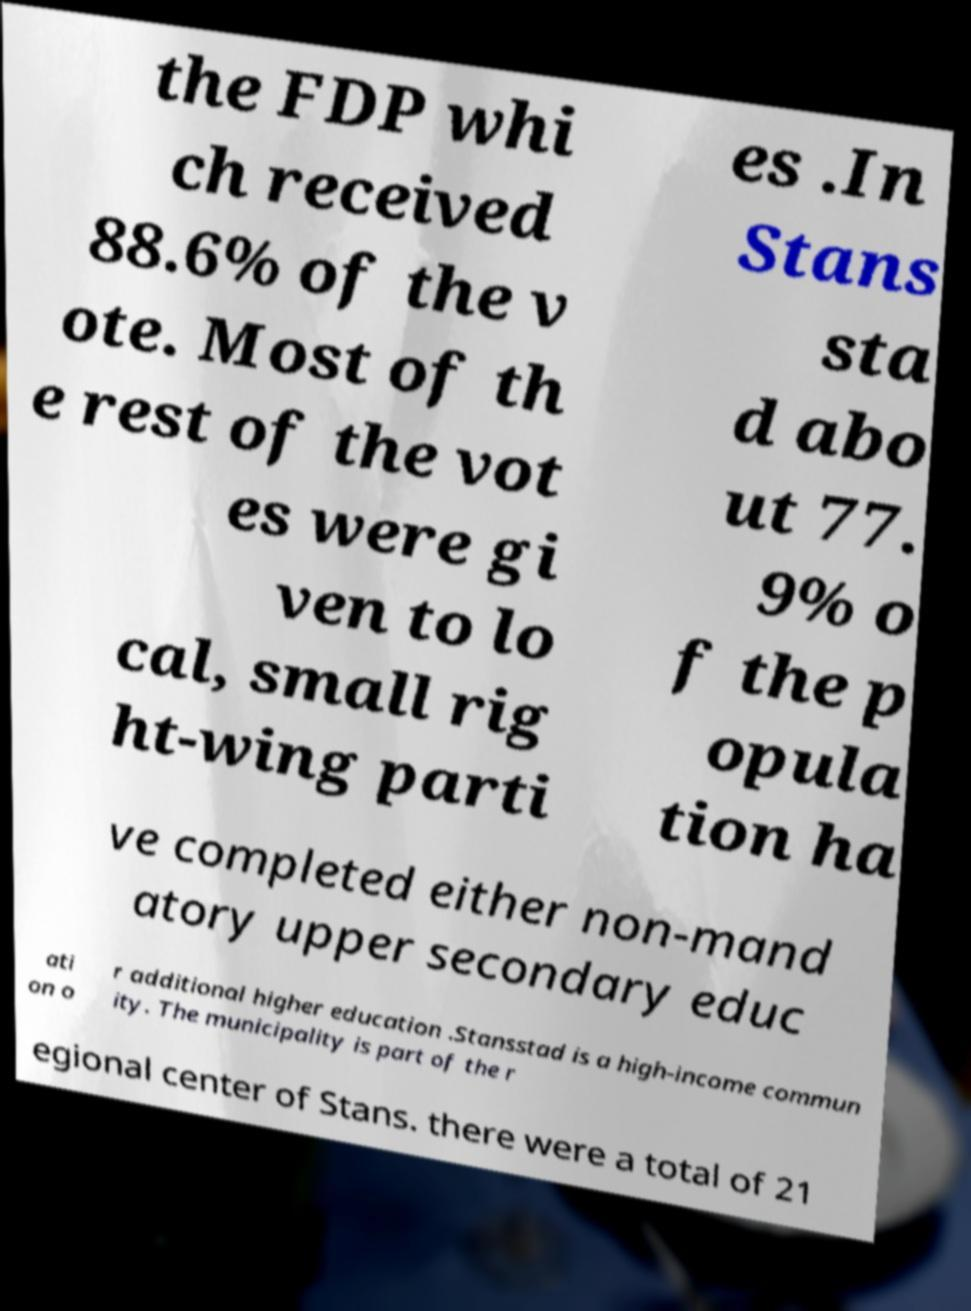Please read and relay the text visible in this image. What does it say? the FDP whi ch received 88.6% of the v ote. Most of th e rest of the vot es were gi ven to lo cal, small rig ht-wing parti es .In Stans sta d abo ut 77. 9% o f the p opula tion ha ve completed either non-mand atory upper secondary educ ati on o r additional higher education .Stansstad is a high-income commun ity. The municipality is part of the r egional center of Stans. there were a total of 21 